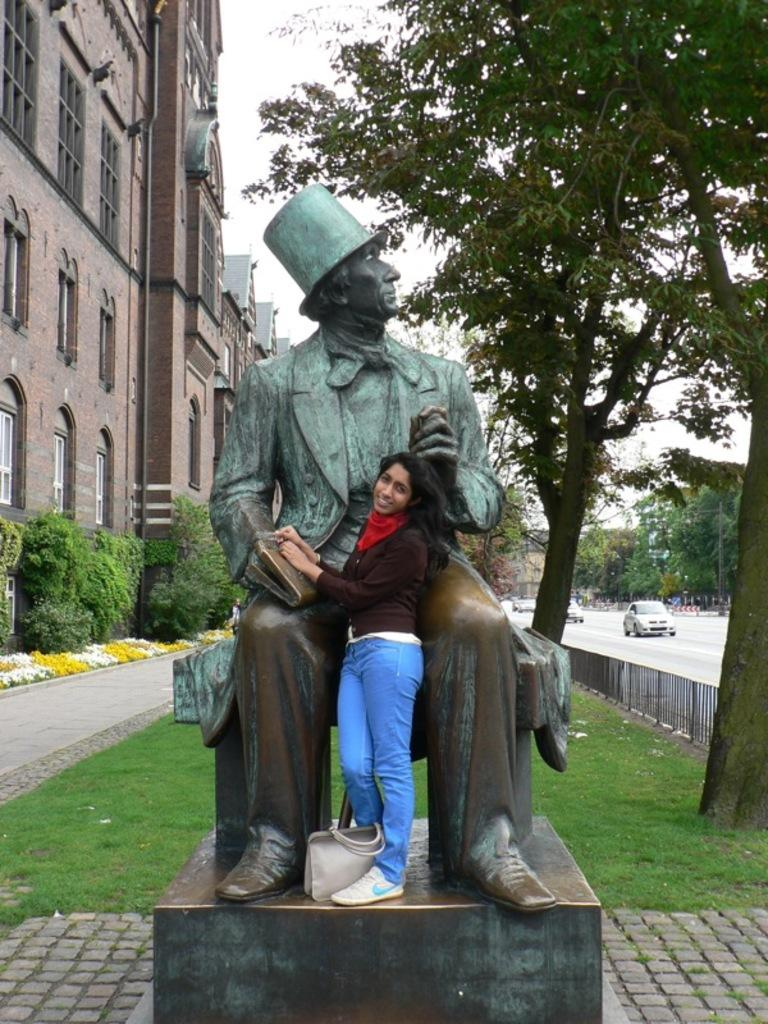Who is the main subject in the image? There is a lady in the image. What is the lady standing in front of? The lady is standing in front of a statue. What can be seen in the background of the image? There are buildings, cars, and trees in the background of the image. What type of surface is the lady standing on? There is grass on the floor in the image. What type of ear is visible on the lady in the image? There is no ear visible on the lady in the image, as the focus is on her standing in front of a statue. 